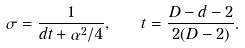<formula> <loc_0><loc_0><loc_500><loc_500>\sigma = \frac { 1 } { d t + \alpha ^ { 2 } / 4 } , \quad t = \frac { D - d - 2 } { 2 ( D - 2 ) } .</formula> 